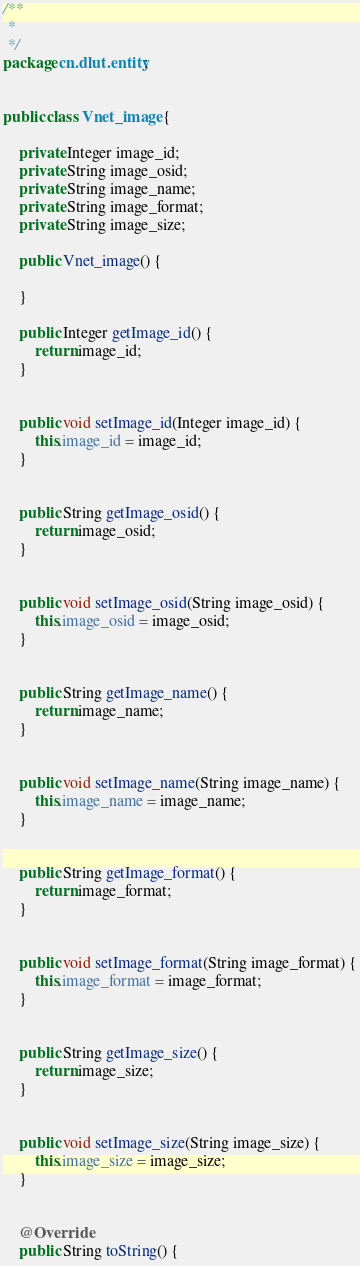Convert code to text. <code><loc_0><loc_0><loc_500><loc_500><_Java_>/**
 * 
 */
package cn.dlut.entity;


public class Vnet_image {

	private Integer image_id;
	private String image_osid;
	private String image_name;
	private String image_format;
	private String image_size;
	
	public Vnet_image() {
		
	}

	public Integer getImage_id() {
		return image_id;
	}


	public void setImage_id(Integer image_id) {
		this.image_id = image_id;
	}


	public String getImage_osid() {
		return image_osid;
	}


	public void setImage_osid(String image_osid) {
		this.image_osid = image_osid;
	}


	public String getImage_name() {
		return image_name;
	}


	public void setImage_name(String image_name) {
		this.image_name = image_name;
	}


	public String getImage_format() {
		return image_format;
	}


	public void setImage_format(String image_format) {
		this.image_format = image_format;
	}


	public String getImage_size() {
		return image_size;
	}


	public void setImage_size(String image_size) {
		this.image_size = image_size;
	}


	@Override
	public String toString() {</code> 